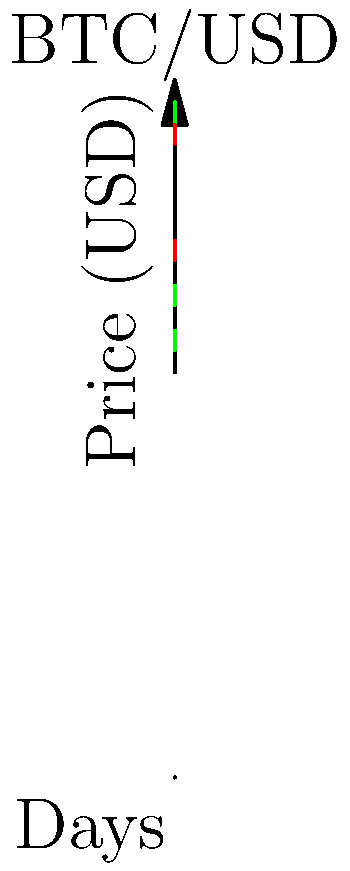Analyze the given 5-day BTC/USD candlestick chart. If you had invested $10,000 at the opening price on Day 0 and sold at the closing price on Day 4, what would be your percentage gain or loss? Round your answer to two decimal places. To solve this problem, we need to follow these steps:

1. Identify the opening price on Day 0:
   The opening price on Day 0 is $10,000.

2. Identify the closing price on Day 4:
   The closing price on Day 4 is $12,000.

3. Calculate the change in value:
   Change = Closing price - Opening price
   Change = $12,000 - $10,000 = $2,000

4. Calculate the percentage change:
   Percentage change = (Change / Opening price) × 100
   Percentage change = ($2,000 / $10,000) × 100 = 20%

Therefore, the investment would have gained 20%.
Answer: 20% gain 